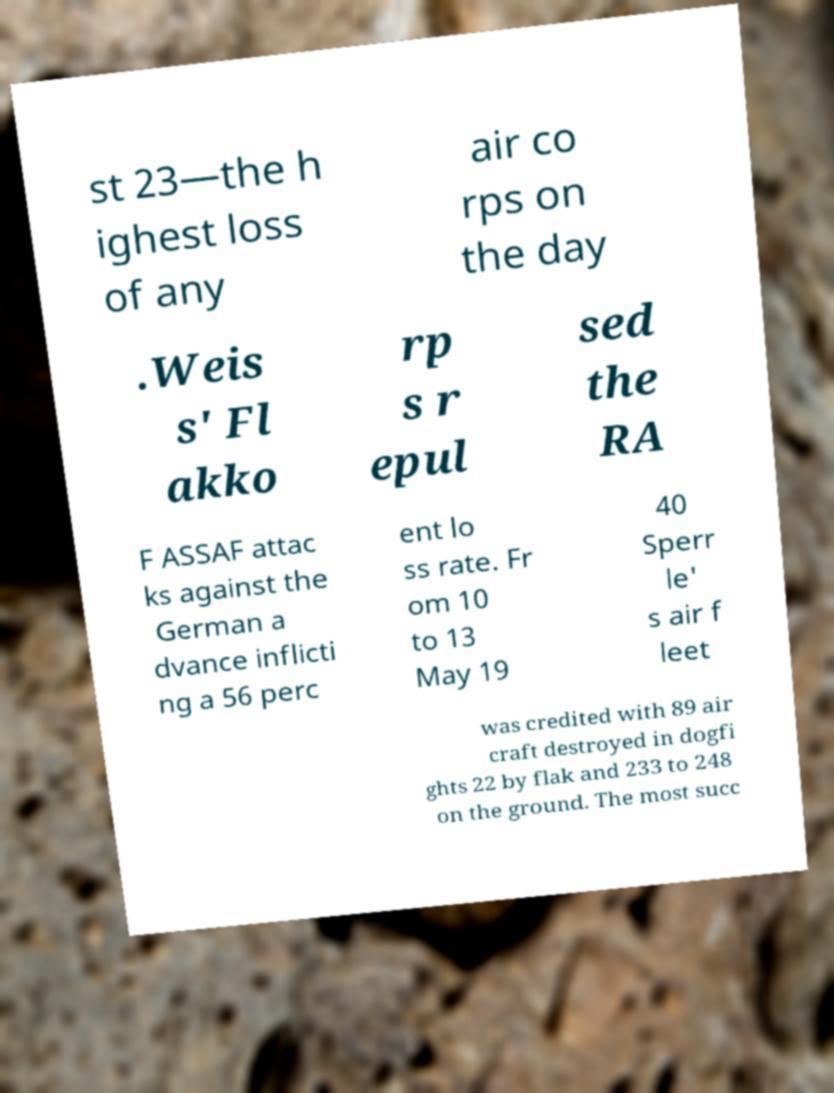Please read and relay the text visible in this image. What does it say? st 23—the h ighest loss of any air co rps on the day .Weis s' Fl akko rp s r epul sed the RA F ASSAF attac ks against the German a dvance inflicti ng a 56 perc ent lo ss rate. Fr om 10 to 13 May 19 40 Sperr le' s air f leet was credited with 89 air craft destroyed in dogfi ghts 22 by flak and 233 to 248 on the ground. The most succ 